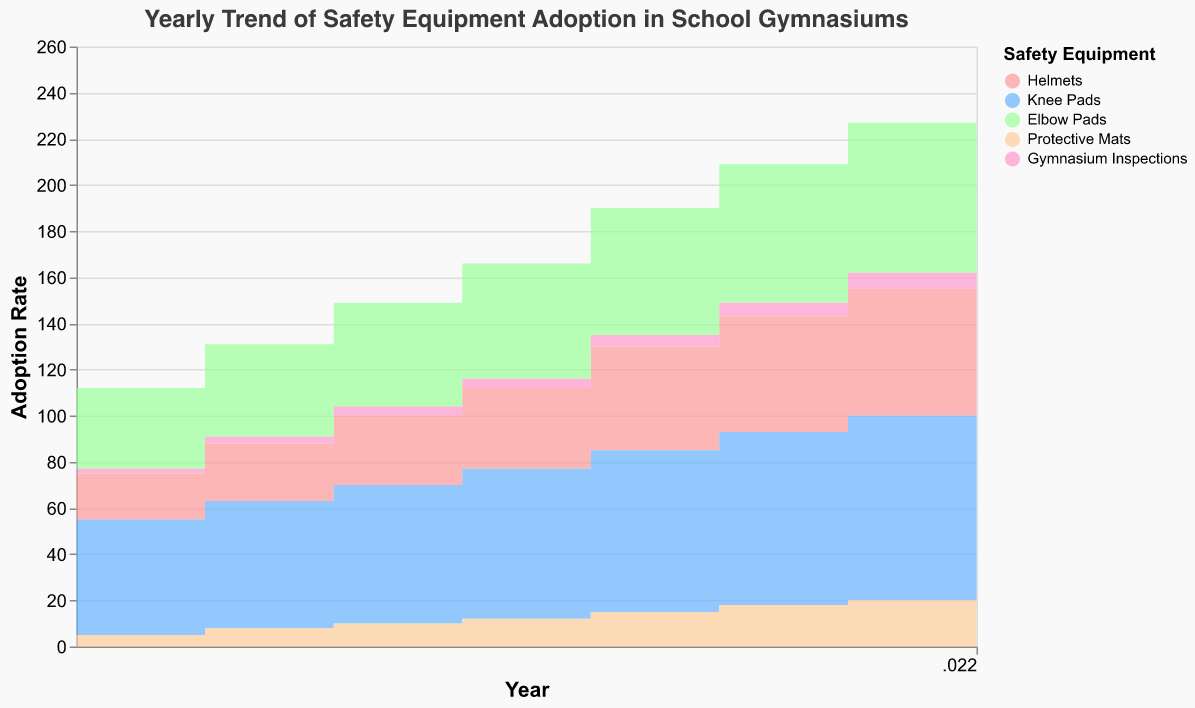What does the title of the chart indicate? The title "Yearly Trend of Safety Equipment Adoption in School Gymnasiums" indicates that the chart shows the changes in the use of safety equipment in school gymnasiums over multiple years.
Answer: Yearly Trend of Safety Equipment Adoption in School Gymnasiums What are the different types of safety equipment shown in the chart? The safety equipment types depicted in the chart are Helmets, Knee Pads, Elbow Pads, Protective Mats, and Gymnasium Inspections.
Answer: Helmets, Knee Pads, Elbow Pads, Protective Mats, Gymnasium Inspections In which year were Gymnasium Inspections adopted the most? By looking at the chart, we can see that Gymnasium Inspections have the highest adoption rate in the year 2022, where the value reaches 8.
Answer: 2022 How much did the adoption of Helmets increase from 2015 to 2022? The adoption of Helmets in 2015 was 20, and it increased to 60 in 2022. The increase is calculated as 60 - 20 = 40.
Answer: 40 Compare the adoption rates of Knee Pads and Elbow Pads in 2019. Which one is higher? In 2019, the adoption rate for Knee Pads is 70, while for Elbow Pads it is 55. By comparing these values, we can see that Knee Pads have a higher adoption rate than Elbow Pads in 2019.
Answer: Knee Pads What is the average number of Protective Mats adopted from 2015 to 2022? To find the average, sum the values of Protective Mats for each year: 5, 8, 10, 12, 15, 18, 20, and 25. The total is 113. Divide the total by the number of years, which is 8. The average is 113 / 8 = 14.125
Answer: 14.125 By how much did the number of Gymnasium Inspections increase from 2015 to 2020? The number of Gymnasium Inspections was 2 in 2015 and 6 in 2020. The increase is calculated as 6 - 2 = 4.
Answer: 4 Which safety equipment's adoption rate showed the most consistent increase over the years? All safety equipment types show a trend of increase, but by examining the chart, Knee Pads exhibit a very consistent and steady rise in adoption rates over the years from 50 in 2015 to 85 in 2022.
Answer: Knee Pads Explain the trend observed in the adoption rates of Protective Mats from 2015 to 2022. The adoption of Protective Mats has steadily increased from 5 in 2015 to 25 in 2022. This indicates a growing emphasis on safety measures in school gymnasiums over the years. The rate of increase also shows slight acceleration, with bigger increments in later years.
Answer: Steady increase from 5 to 25 What relationship can you observe between Gymnasium Inspections and the adoption of other safety equipment? There appears to be a correlation where the number of Gymnasium Inspections increases coinciding with the rising adoption of other safety equipment like Helmets, Knee Pads, Elbow Pads, and Protective Mats. This suggests that increased inspections might encourage the adoption of safety measures.
Answer: Positive correlation 